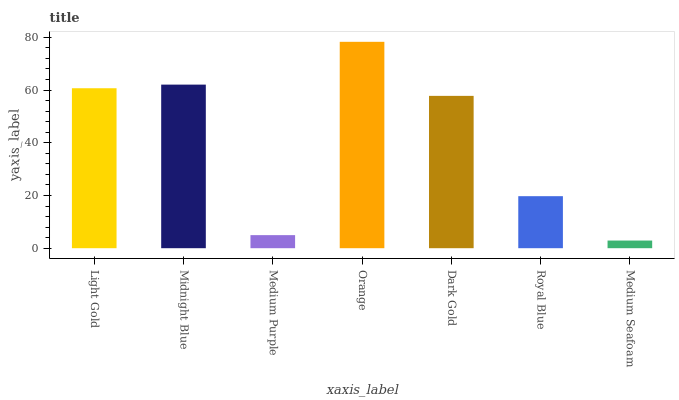Is Medium Seafoam the minimum?
Answer yes or no. Yes. Is Orange the maximum?
Answer yes or no. Yes. Is Midnight Blue the minimum?
Answer yes or no. No. Is Midnight Blue the maximum?
Answer yes or no. No. Is Midnight Blue greater than Light Gold?
Answer yes or no. Yes. Is Light Gold less than Midnight Blue?
Answer yes or no. Yes. Is Light Gold greater than Midnight Blue?
Answer yes or no. No. Is Midnight Blue less than Light Gold?
Answer yes or no. No. Is Dark Gold the high median?
Answer yes or no. Yes. Is Dark Gold the low median?
Answer yes or no. Yes. Is Medium Purple the high median?
Answer yes or no. No. Is Medium Purple the low median?
Answer yes or no. No. 